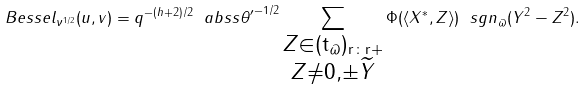<formula> <loc_0><loc_0><loc_500><loc_500>\ B e s s e l _ { \nu ^ { 1 / 2 } } ( u , v ) = q ^ { - ( h + 2 ) / 2 } \ a b s { s \theta ^ { \prime } } ^ { - 1 / 2 } \sum _ { \substack { Z \in ( \tt t _ { \varpi } ) _ { r \colon r { + } } \\ Z \ne 0 , \pm \widetilde { Y } } } \Phi ( \langle X ^ { * } , Z \rangle ) \ s g n _ { \varpi } ( Y ^ { 2 } - Z ^ { 2 } ) .</formula> 